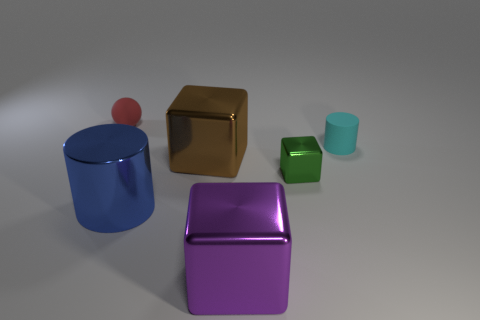The metal cylinder is what size?
Your answer should be very brief. Large. How many objects are either small red spheres or metallic objects?
Your response must be concise. 5. There is a cylinder behind the big blue metal cylinder; what size is it?
Provide a succinct answer. Small. Are there any other things that have the same size as the red rubber thing?
Provide a short and direct response. Yes. What color is the large metallic object that is both right of the big blue shiny cylinder and in front of the green object?
Make the answer very short. Purple. Are the cylinder in front of the cyan rubber cylinder and the tiny cylinder made of the same material?
Give a very brief answer. No. Is the color of the matte sphere the same as the cylinder to the left of the tiny cyan cylinder?
Keep it short and to the point. No. There is a big purple object; are there any big purple shiny objects right of it?
Provide a succinct answer. No. There is a cube that is to the left of the purple cube; is its size the same as the cylinder that is to the left of the cyan rubber cylinder?
Your response must be concise. Yes. Are there any brown metallic objects that have the same size as the red matte thing?
Make the answer very short. No. 